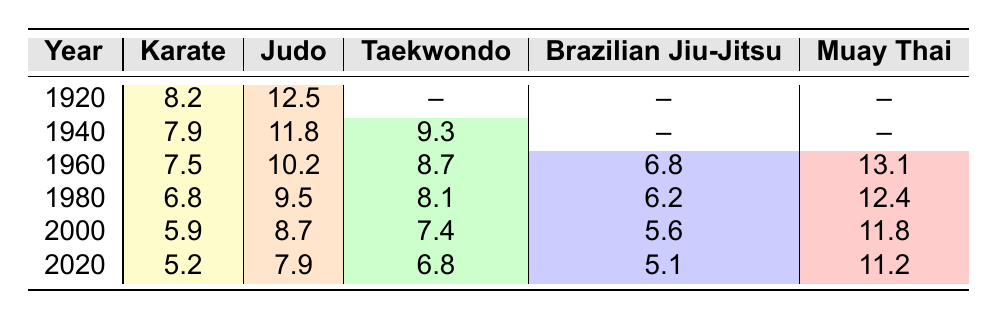What was the injury rate for Judo in 1960? The table shows a specific value for Judo in 1960, which is 10.2.
Answer: 10.2 What martial art had the highest injury rate in 1980? Referring to the 1980 row in the table, Muay Thai had an injury rate of 12.4, which is the highest comparing to others listed in that year.
Answer: Muay Thai Which martial art consistently had the lowest injury rate from 1960 to 2020? By observing the table from 1960 to 2020, Karate had the lowest injury rates over these years with values decreasing from 7.5 in 1960 to 5.2 in 2020.
Answer: Karate What was the average injury rate for Taekwondo over the recorded years? Taekwondo values are available for 1940 (9.3), 1960 (8.7), 1980 (8.1), 2000 (7.4), and 2020 (6.8). Summing these values gives 40.3, and dividing by 5 gives an average of 8.06.
Answer: 8.06 Is it true that the injury rate for Brazilian Jiu-Jitsu in 2000 was higher than for Karate that same year? In 2000, Brazilian Jiu-Jitsu had an injury rate of 5.6 while Karate had a value of 5.9. Thus, it is false that Brazilian Jiu-Jitsu was higher than Karate in that year.
Answer: No What trend can be observed in the injury rates for Judo and Karate from 1920 to 2020? By analyzing the data, both Judo and Karate show a decreasing trend in injury rates over the century. Judo decreases from 12.5 in 1920 to 7.9 in 2020, and Karate decreases from 8.2 to 5.2.
Answer: Decreasing trend Which martial art showed a notable increase in injury rate from 1960 to 1960? By analyzing the values in 1960, Muay Thai showed an injury rate of 13.1, which was higher compared to all other disciplines, notably higher than Brazilian Jiu-Jitsu’s 6.8. This indicates a relative increase for Muay Thai compared to others but doesn't indicate an increase over a previous value. The original question likely intended a different comparison.
Answer: Not applicable What is the difference in injury rate between Judo and Muay Thai in 2000? In 2000, Judo had an injury rate of 8.7 and Muay Thai had 11.8. The difference is 11.8 - 8.7 = 3.1.
Answer: 3.1 In which year did Taekwondo have its highest injury rate, and what was that rate? The highest injury rate for Taekwondo was in 1940 with a value of 9.3.
Answer: 1940, 9.3 Based on the data, how did the injury rate for any martial art shift from 1920 to 2020? Analysis shows all martial arts reported a decrease in injury rates from 1920 to 2020, with Karate decreasing from 8.2 to 5.2, Judo from 12.5 to 7.9, and others also showing downward trends.
Answer: Decreased for all martial arts 